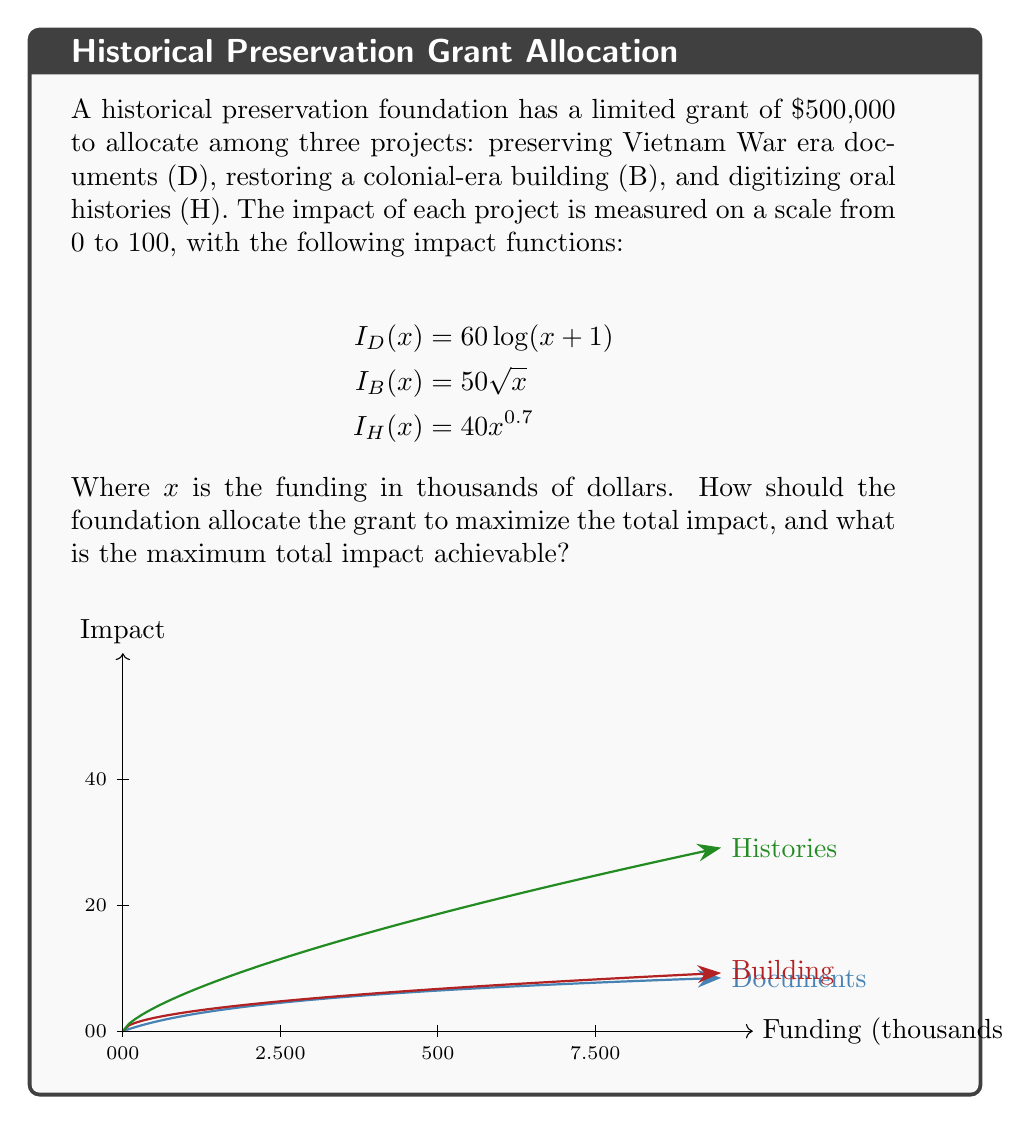Show me your answer to this math problem. To solve this optimization problem, we'll use the method of Lagrange multipliers:

1) Let $x$, $y$, and $z$ be the funding (in thousands) for D, B, and H respectively.

2) Our objective function is:
   $$ f(x,y,z) = 60\log(x+1) + 50\sqrt{y} + 40z^{0.7} $$

3) The constraint is:
   $$ g(x,y,z) = x + y + z - 500 = 0 $$

4) Form the Lagrangian:
   $$ L(x,y,z,\lambda) = 60\log(x+1) + 50\sqrt{y} + 40z^{0.7} - \lambda(x + y + z - 500) $$

5) Set partial derivatives to zero:
   $$ \frac{\partial L}{\partial x} = \frac{60}{x+1} - \lambda = 0 $$
   $$ \frac{\partial L}{\partial y} = \frac{25}{\sqrt{y}} - \lambda = 0 $$
   $$ \frac{\partial L}{\partial z} = \frac{28}{z^{0.3}} - \lambda = 0 $$
   $$ \frac{\partial L}{\partial \lambda} = x + y + z - 500 = 0 $$

6) From these equations:
   $$ x = \frac{60}{\lambda} - 1 $$
   $$ y = (\frac{25}{\lambda})^2 $$
   $$ z = (\frac{28}{\lambda})^{\frac{10}{3}} $$

7) Substitute into the constraint:
   $$ (\frac{60}{\lambda} - 1) + (\frac{25}{\lambda})^2 + (\frac{28}{\lambda})^{\frac{10}{3}} = 500 $$

8) Solve numerically to get $\lambda \approx 0.2404$

9) Substitute back to get:
   $x \approx 248.6$, $y \approx 108.1$, $z \approx 143.3$

10) The maximum total impact is:
    $$ 60\log(248.6+1) + 50\sqrt{108.1} + 40(143.3)^{0.7} \approx 330.7 $$
Answer: Allocate $248,600 to documents, $108,100 to building, $143,300 to histories. Maximum impact: 330.7 